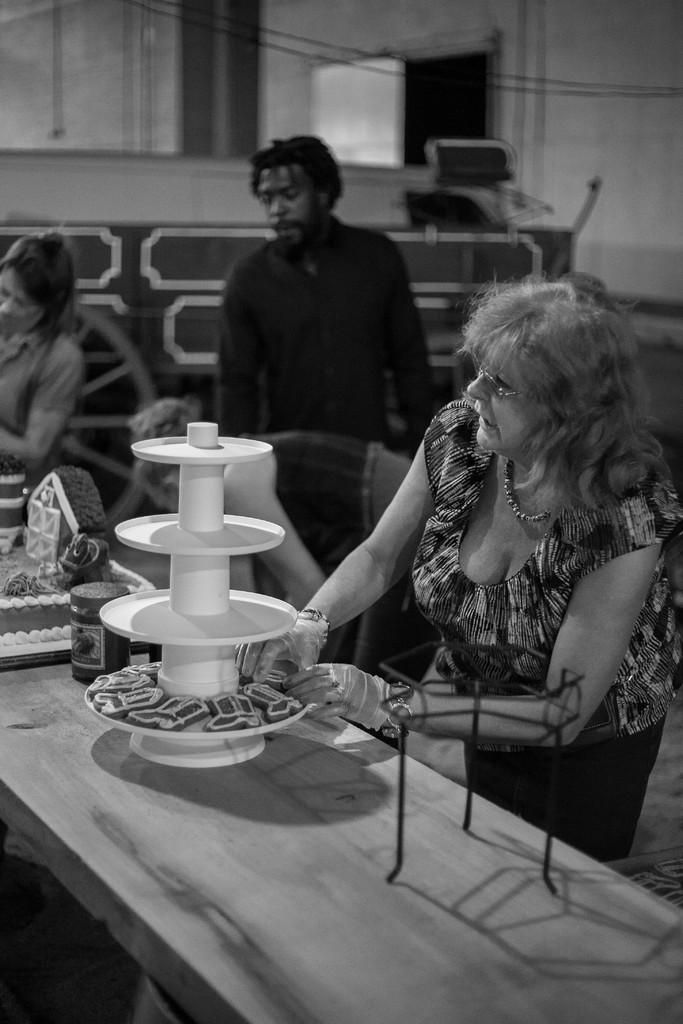What is the color scheme of the image? The image is black and white. What can be seen in the image besides the color scheme? There are people standing in the image, and there is a table in front of them. What is on the table in the image? There is a cake, a jar, and cookies on the table. What is the smell of the cake in the image? The image is in black and white, so it is not possible to determine the smell of the cake. 